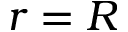<formula> <loc_0><loc_0><loc_500><loc_500>r = R</formula> 